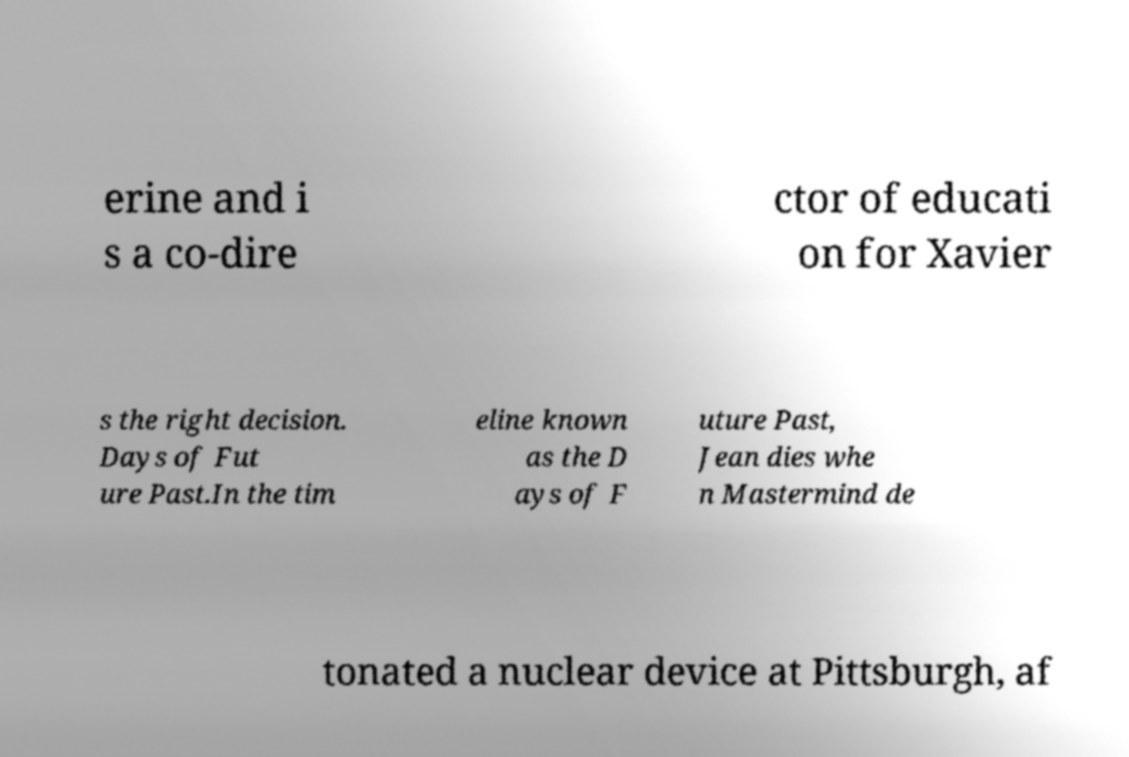For documentation purposes, I need the text within this image transcribed. Could you provide that? erine and i s a co-dire ctor of educati on for Xavier s the right decision. Days of Fut ure Past.In the tim eline known as the D ays of F uture Past, Jean dies whe n Mastermind de tonated a nuclear device at Pittsburgh, af 